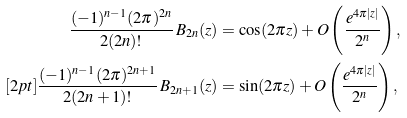Convert formula to latex. <formula><loc_0><loc_0><loc_500><loc_500>\frac { ( - 1 ) ^ { n - 1 } ( 2 \pi ) ^ { 2 n } } { 2 ( 2 n ) ! } \, B _ { 2 n } ( z ) & = \cos ( 2 \pi z ) + O \left ( \frac { e ^ { 4 \pi | z | } } { 2 ^ { n } } \right ) , \\ [ 2 p t ] \frac { ( - 1 ) ^ { n - 1 } ( 2 \pi ) ^ { 2 n + 1 } } { 2 ( 2 n + 1 ) ! } \, B _ { 2 n + 1 } ( z ) & = \sin ( 2 \pi z ) + O \left ( \frac { e ^ { 4 \pi | z | } } { 2 ^ { n } } \right ) ,</formula> 